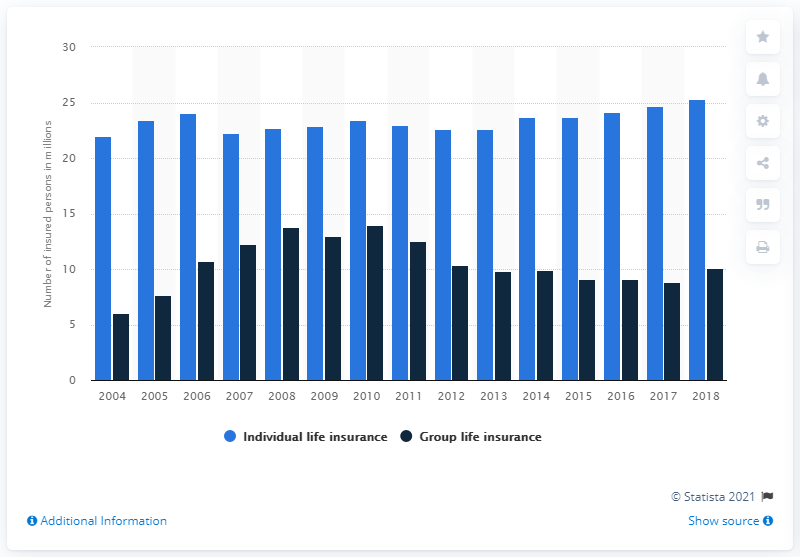Mention a couple of crucial points in this snapshot. In 2018, there were 25,350 individuals who were covered by individual life insurance in Italy. 